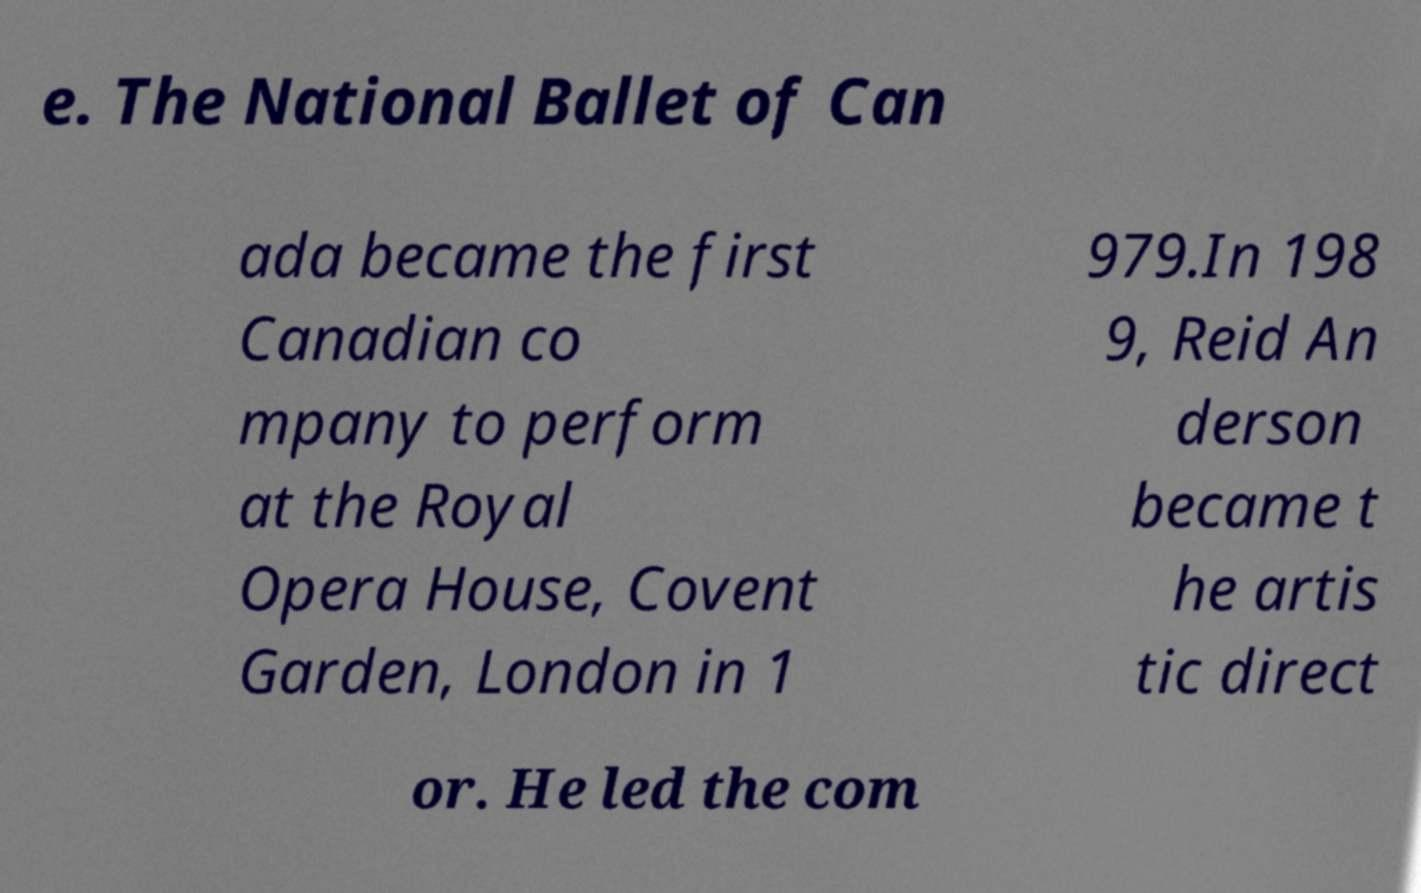Could you extract and type out the text from this image? e. The National Ballet of Can ada became the first Canadian co mpany to perform at the Royal Opera House, Covent Garden, London in 1 979.In 198 9, Reid An derson became t he artis tic direct or. He led the com 